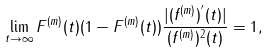Convert formula to latex. <formula><loc_0><loc_0><loc_500><loc_500>\lim _ { t \rightarrow \infty } F ^ { ( m ) } ( t ) ( 1 - F ^ { ( m ) } ( t ) ) \frac { | ( f ^ { ( m ) } ) ^ { ^ { \prime } } ( t ) | } { ( f ^ { ( m ) } ) ^ { 2 } ( t ) } = 1 ,</formula> 